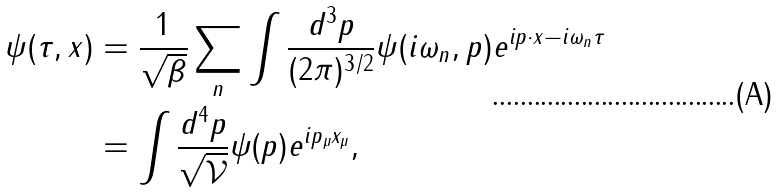<formula> <loc_0><loc_0><loc_500><loc_500>\psi ( \tau , x ) & = \frac { 1 } { \sqrt { \beta } } \sum _ { n } \int \frac { d ^ { 3 } p } { ( 2 \pi ) ^ { 3 / 2 } } \psi ( i \omega _ { n } , p ) e ^ { i p \cdot x - i \omega _ { n } \tau } \\ & = \int \frac { d ^ { 4 } p } { \sqrt { \mathcal { V } } } \psi ( p ) e ^ { i p _ { \mu } x _ { \mu } } ,</formula> 